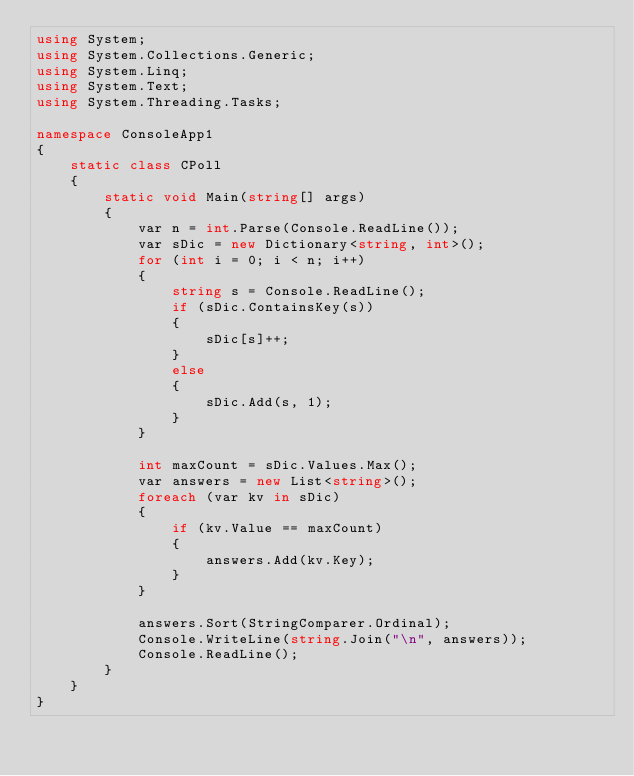<code> <loc_0><loc_0><loc_500><loc_500><_C#_>using System;
using System.Collections.Generic;
using System.Linq;
using System.Text;
using System.Threading.Tasks;

namespace ConsoleApp1
{
    static class CPoll
    {
        static void Main(string[] args)
        {
            var n = int.Parse(Console.ReadLine());
            var sDic = new Dictionary<string, int>();
            for (int i = 0; i < n; i++)
            {
                string s = Console.ReadLine();
                if (sDic.ContainsKey(s))
                {
                    sDic[s]++;
                }
                else
                {
                    sDic.Add(s, 1);
                }
            }

            int maxCount = sDic.Values.Max();
            var answers = new List<string>();
            foreach (var kv in sDic)
            {
                if (kv.Value == maxCount)
                {
                    answers.Add(kv.Key);
                }
            }

            answers.Sort(StringComparer.Ordinal);
            Console.WriteLine(string.Join("\n", answers));
            Console.ReadLine();
        }
    }
}</code> 